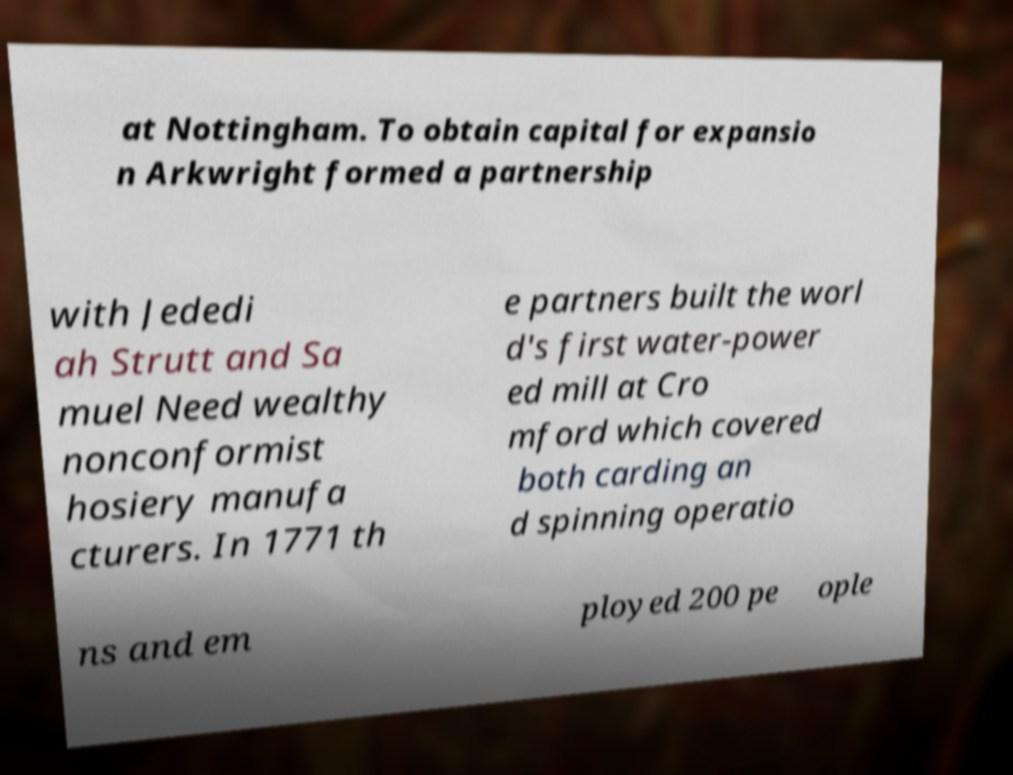Could you assist in decoding the text presented in this image and type it out clearly? at Nottingham. To obtain capital for expansio n Arkwright formed a partnership with Jededi ah Strutt and Sa muel Need wealthy nonconformist hosiery manufa cturers. In 1771 th e partners built the worl d's first water-power ed mill at Cro mford which covered both carding an d spinning operatio ns and em ployed 200 pe ople 